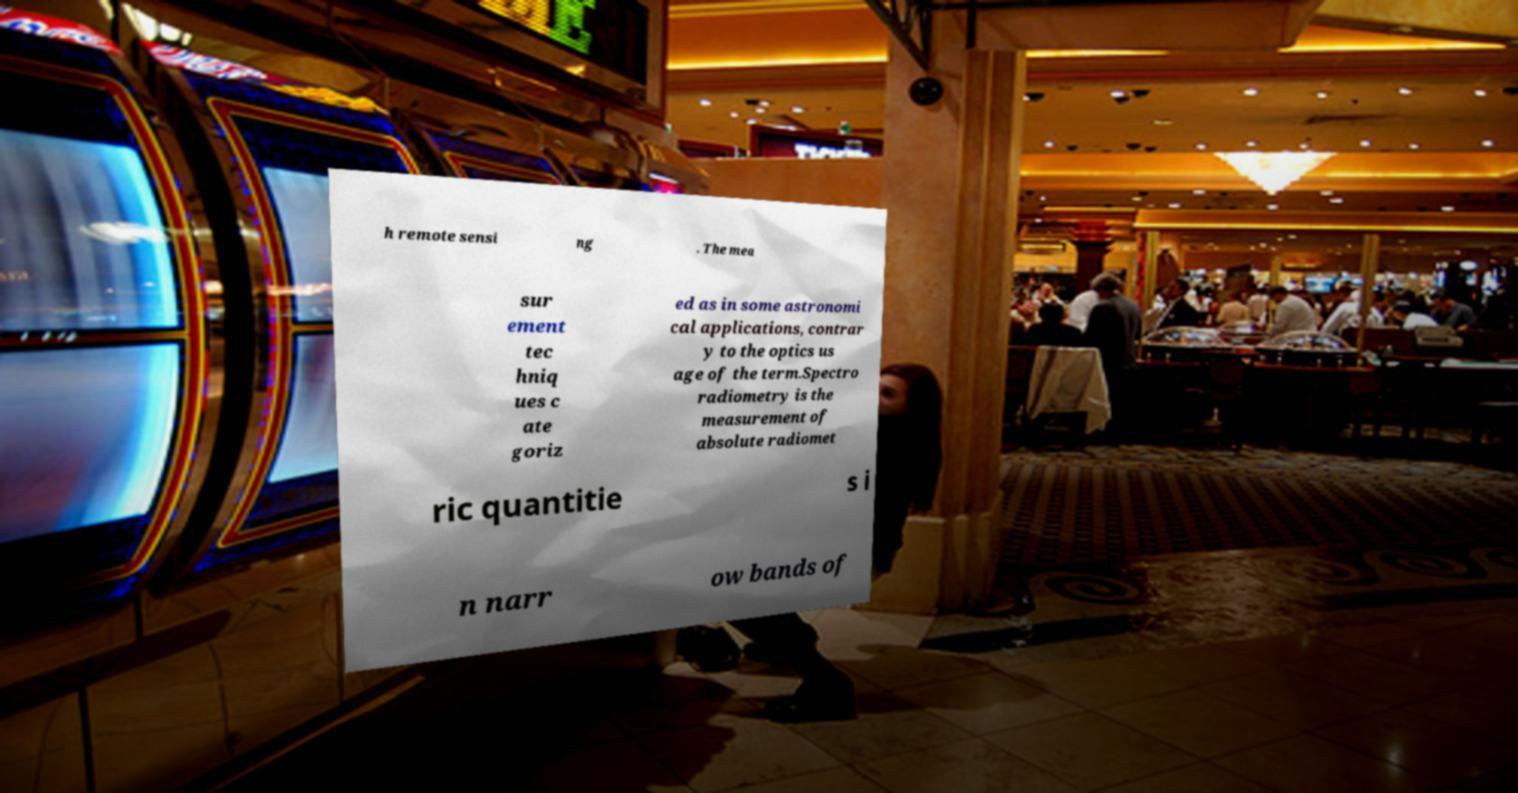Can you read and provide the text displayed in the image?This photo seems to have some interesting text. Can you extract and type it out for me? h remote sensi ng . The mea sur ement tec hniq ues c ate goriz ed as in some astronomi cal applications, contrar y to the optics us age of the term.Spectro radiometry is the measurement of absolute radiomet ric quantitie s i n narr ow bands of 